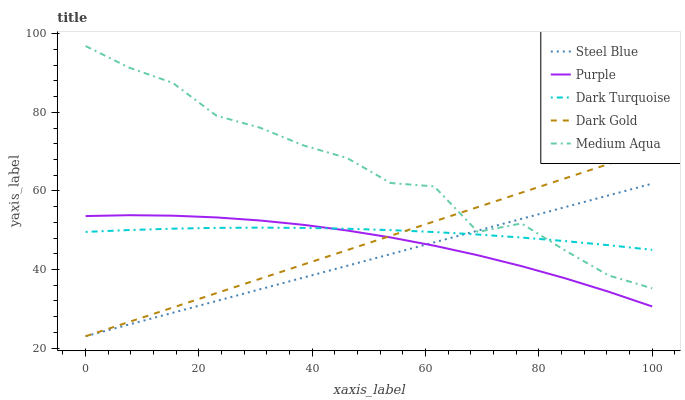Does Steel Blue have the minimum area under the curve?
Answer yes or no. Yes. Does Medium Aqua have the maximum area under the curve?
Answer yes or no. Yes. Does Dark Turquoise have the minimum area under the curve?
Answer yes or no. No. Does Dark Turquoise have the maximum area under the curve?
Answer yes or no. No. Is Dark Gold the smoothest?
Answer yes or no. Yes. Is Medium Aqua the roughest?
Answer yes or no. Yes. Is Dark Turquoise the smoothest?
Answer yes or no. No. Is Dark Turquoise the roughest?
Answer yes or no. No. Does Steel Blue have the lowest value?
Answer yes or no. Yes. Does Medium Aqua have the lowest value?
Answer yes or no. No. Does Medium Aqua have the highest value?
Answer yes or no. Yes. Does Dark Turquoise have the highest value?
Answer yes or no. No. Is Purple less than Medium Aqua?
Answer yes or no. Yes. Is Medium Aqua greater than Purple?
Answer yes or no. Yes. Does Dark Gold intersect Steel Blue?
Answer yes or no. Yes. Is Dark Gold less than Steel Blue?
Answer yes or no. No. Is Dark Gold greater than Steel Blue?
Answer yes or no. No. Does Purple intersect Medium Aqua?
Answer yes or no. No. 